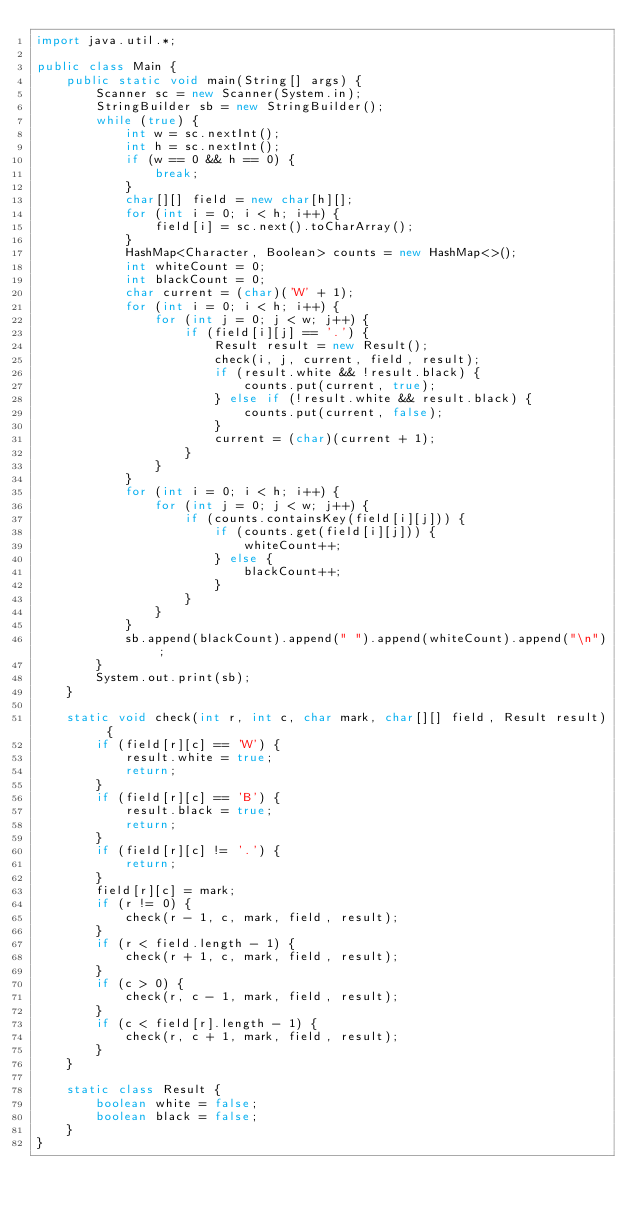Convert code to text. <code><loc_0><loc_0><loc_500><loc_500><_Java_>import java.util.*;

public class Main {
    public static void main(String[] args) {
        Scanner sc = new Scanner(System.in);
        StringBuilder sb = new StringBuilder();
        while (true) {
            int w = sc.nextInt();
            int h = sc.nextInt();
            if (w == 0 && h == 0) {
                break;
            }
            char[][] field = new char[h][];
            for (int i = 0; i < h; i++) {
                field[i] = sc.next().toCharArray();
            }
            HashMap<Character, Boolean> counts = new HashMap<>();
            int whiteCount = 0;
            int blackCount = 0;
            char current = (char)('W' + 1);
            for (int i = 0; i < h; i++) {
                for (int j = 0; j < w; j++) {
                    if (field[i][j] == '.') {
                        Result result = new Result();
                        check(i, j, current, field, result);
                        if (result.white && !result.black) {
                            counts.put(current, true);
                        } else if (!result.white && result.black) {
                            counts.put(current, false);
                        }
                        current = (char)(current + 1);
                    }
                }
            }
            for (int i = 0; i < h; i++) {
                for (int j = 0; j < w; j++) {
                    if (counts.containsKey(field[i][j])) {
                        if (counts.get(field[i][j])) {
                            whiteCount++;
                        } else {
                            blackCount++;
                        }
                    }
                }
            }
            sb.append(blackCount).append(" ").append(whiteCount).append("\n");
        }
        System.out.print(sb);
    }
    
    static void check(int r, int c, char mark, char[][] field, Result result) {
        if (field[r][c] == 'W') {
            result.white = true;
            return;
        }
        if (field[r][c] == 'B') {
            result.black = true;
            return;
        }
        if (field[r][c] != '.') {
            return;
        }
        field[r][c] = mark;
        if (r != 0) {
            check(r - 1, c, mark, field, result);
        }
        if (r < field.length - 1) {
            check(r + 1, c, mark, field, result);
        }
        if (c > 0) {
            check(r, c - 1, mark, field, result);
        }
        if (c < field[r].length - 1) {
            check(r, c + 1, mark, field, result);
        }
    }
    
    static class Result {
        boolean white = false;
        boolean black = false;
    }
}
</code> 